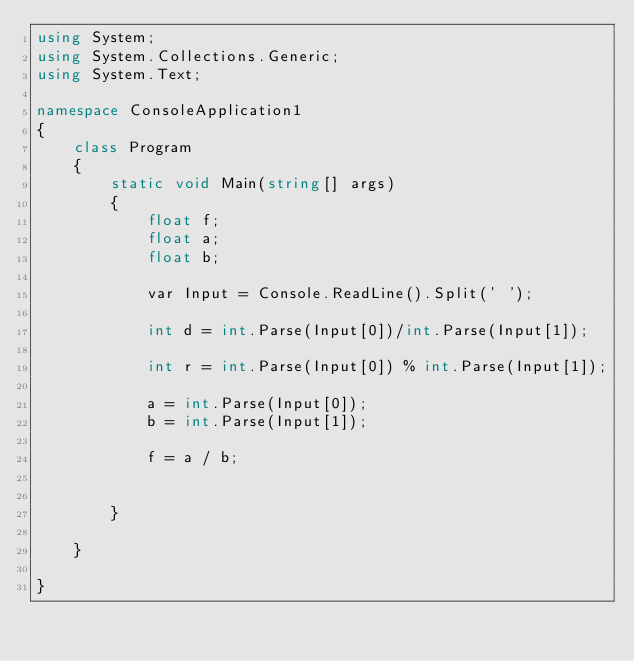Convert code to text. <code><loc_0><loc_0><loc_500><loc_500><_C#_>using System;
using System.Collections.Generic;
using System.Text;

namespace ConsoleApplication1
{
    class Program
    {
        static void Main(string[] args)
        {
            float f;
            float a;
            float b;

            var Input = Console.ReadLine().Split(' ');

            int d = int.Parse(Input[0])/int.Parse(Input[1]);

            int r = int.Parse(Input[0]) % int.Parse(Input[1]);

            a = int.Parse(Input[0]);
            b = int.Parse(Input[1]);

            f = a / b;


        }

    }

}</code> 